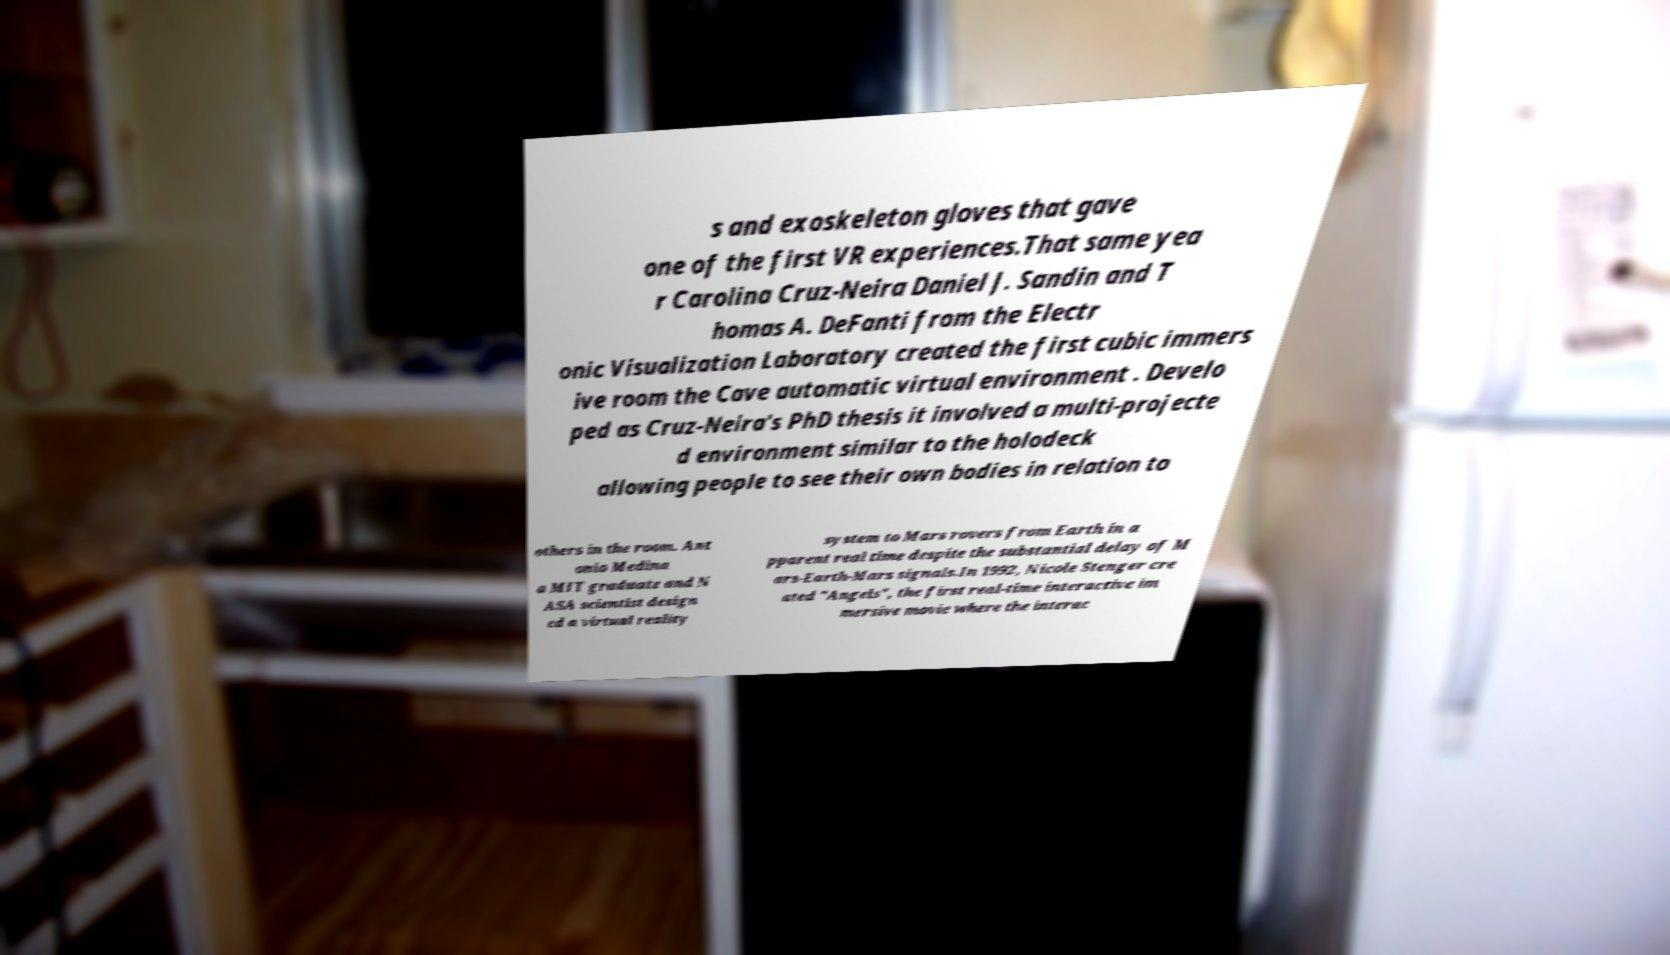What messages or text are displayed in this image? I need them in a readable, typed format. s and exoskeleton gloves that gave one of the first VR experiences.That same yea r Carolina Cruz-Neira Daniel J. Sandin and T homas A. DeFanti from the Electr onic Visualization Laboratory created the first cubic immers ive room the Cave automatic virtual environment . Develo ped as Cruz-Neira's PhD thesis it involved a multi-projecte d environment similar to the holodeck allowing people to see their own bodies in relation to others in the room. Ant onio Medina a MIT graduate and N ASA scientist design ed a virtual reality system to Mars rovers from Earth in a pparent real time despite the substantial delay of M ars-Earth-Mars signals.In 1992, Nicole Stenger cre ated "Angels", the first real-time interactive im mersive movie where the interac 